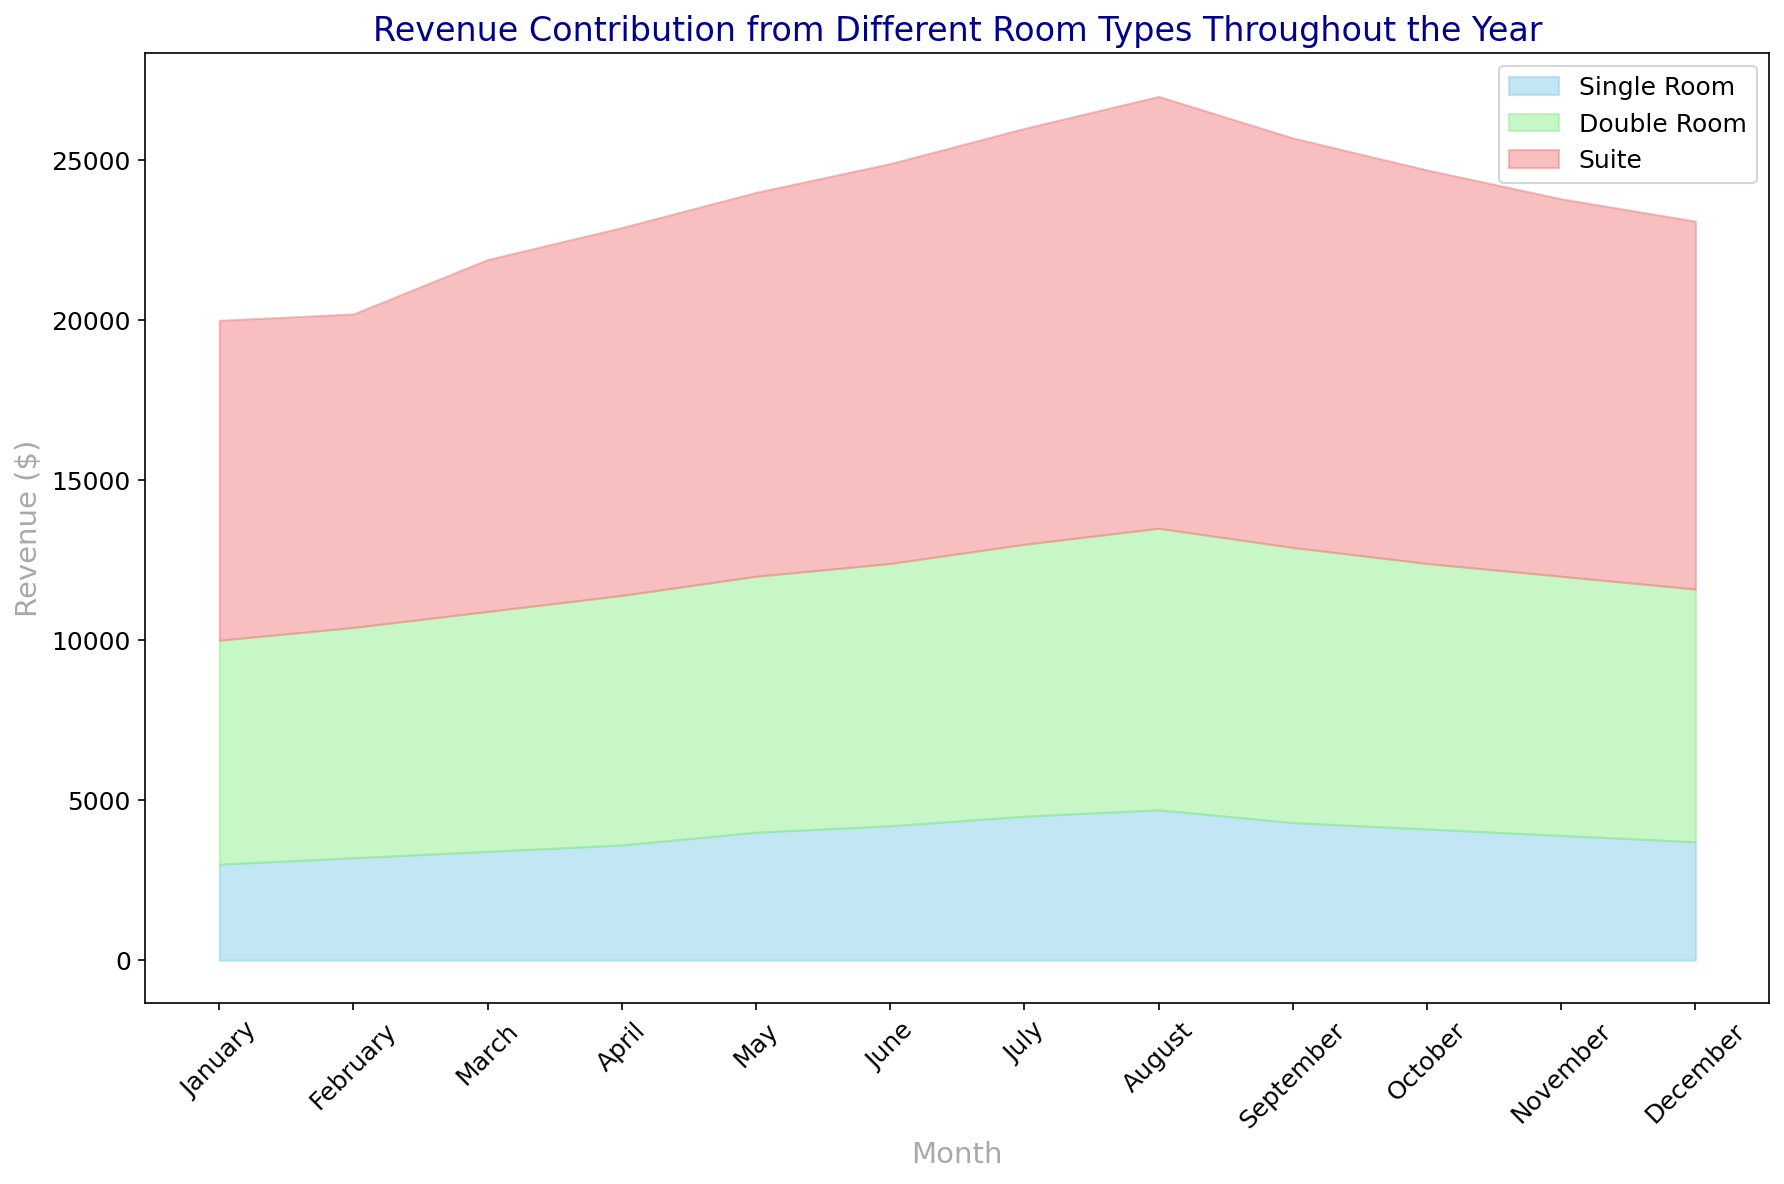Which room type contributed the most revenue in December? Looking at the December part of the area chart, find the band with the largest vertical space. The Suite (red) has the largest space among the three room types.
Answer: Suite In which month did the Single Room revenue reach its peak? Observe the height of the skyblue area for Single Room across all months. June shows the highest point for the Single Room revenue.
Answer: June Between which two consecutive months is the increase in Suite revenue the highest? Relative to previous-month values, compare the increase of the lightcoral (Suite) between each consecutive month. The largest jump happens between February and March.
Answer: February to March What is the total revenue from all room types in July? Add revenues of Single Room (skyblue), Double Room (lightgreen), and Suite (lightcoral) in July: $4500 + $8500 + $13000.
Answer: $26,000 Which month shows the lowest total revenue? Observe where all three areas combined are the shortest vertically. January has the lowest total combined revenue.
Answer: January How much higher is the Double Room revenue in December compared to January? Subtract the Double Room revenue in January from December: $7900 - $7000.
Answer: $900 What is the average revenue of the Suite throughout the year? Sum the monthly Suite revenues and then divide by 12: \[ \(10000 + 9800 + 11000 + 11500 + 12000 + 12500 + 13000 + 13500 + 12800 + 12300 + 11800 + 11500\)/12 = $11,750 \]
Answer: $11,750 Compare the overall trend of Single Room revenue to Double Room revenue. Which one shows a more consistent increase throughout the year? Observe the gradient change year-round for both Single Room (skyblue) and Double Room (lightgreen). While both increase, Single Room has fewer fluctuations than Double Room, showing a steadier incline.
Answer: Single Room During which months does the Suite make up more than half of the total revenue? For each month, compare the height of the Suite (lightcoral) relative to the sum of all heights. March through August show the Suite representing more than half.
Answer: March to August Which month has the smallest difference in revenue between Double Room and Suite? Subtract Double Room revenue from Suite revenue for each month and find the smallest difference. September has the smallest difference: $12800 - $8600 = $4200.
Answer: September 